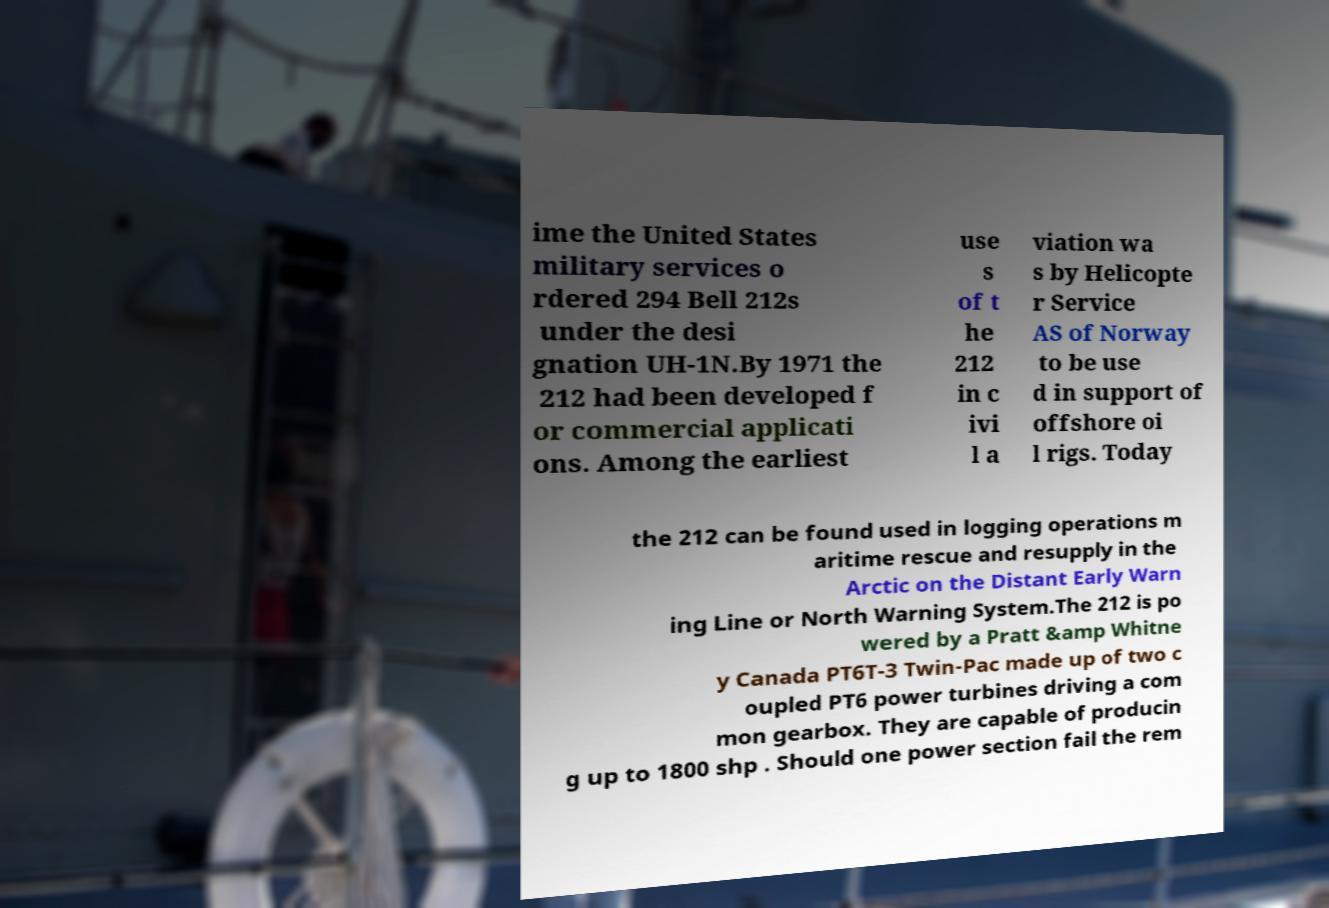What messages or text are displayed in this image? I need them in a readable, typed format. ime the United States military services o rdered 294 Bell 212s under the desi gnation UH-1N.By 1971 the 212 had been developed f or commercial applicati ons. Among the earliest use s of t he 212 in c ivi l a viation wa s by Helicopte r Service AS of Norway to be use d in support of offshore oi l rigs. Today the 212 can be found used in logging operations m aritime rescue and resupply in the Arctic on the Distant Early Warn ing Line or North Warning System.The 212 is po wered by a Pratt &amp Whitne y Canada PT6T-3 Twin-Pac made up of two c oupled PT6 power turbines driving a com mon gearbox. They are capable of producin g up to 1800 shp . Should one power section fail the rem 